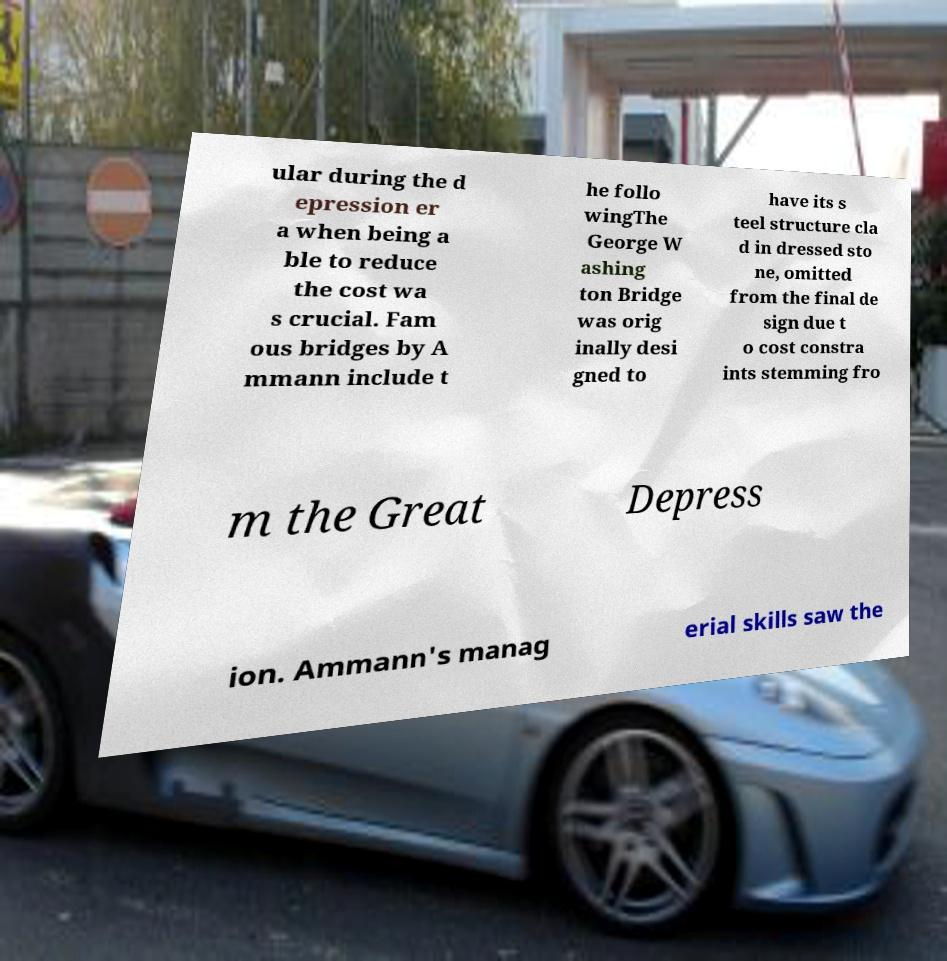Could you extract and type out the text from this image? ular during the d epression er a when being a ble to reduce the cost wa s crucial. Fam ous bridges by A mmann include t he follo wingThe George W ashing ton Bridge was orig inally desi gned to have its s teel structure cla d in dressed sto ne, omitted from the final de sign due t o cost constra ints stemming fro m the Great Depress ion. Ammann's manag erial skills saw the 